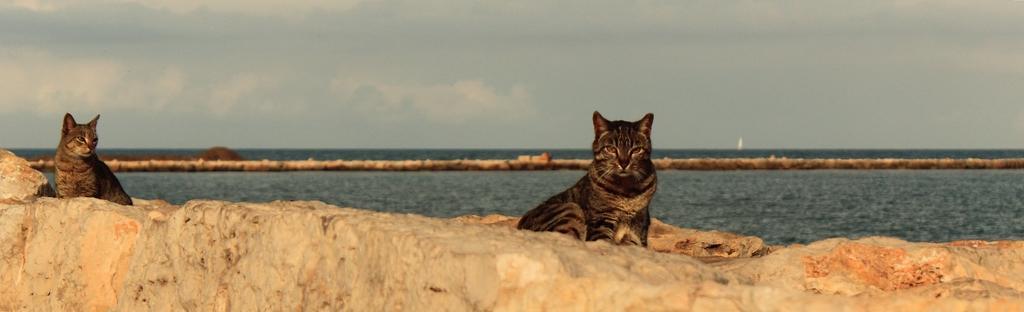How would you summarize this image in a sentence or two? In this image I can see a huge rock which is cream, orange and brown in color and on it I can see two cats. In the background I can see the water, the ground and the sky. 